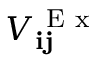<formula> <loc_0><loc_0><loc_500><loc_500>V _ { i j } ^ { E x }</formula> 